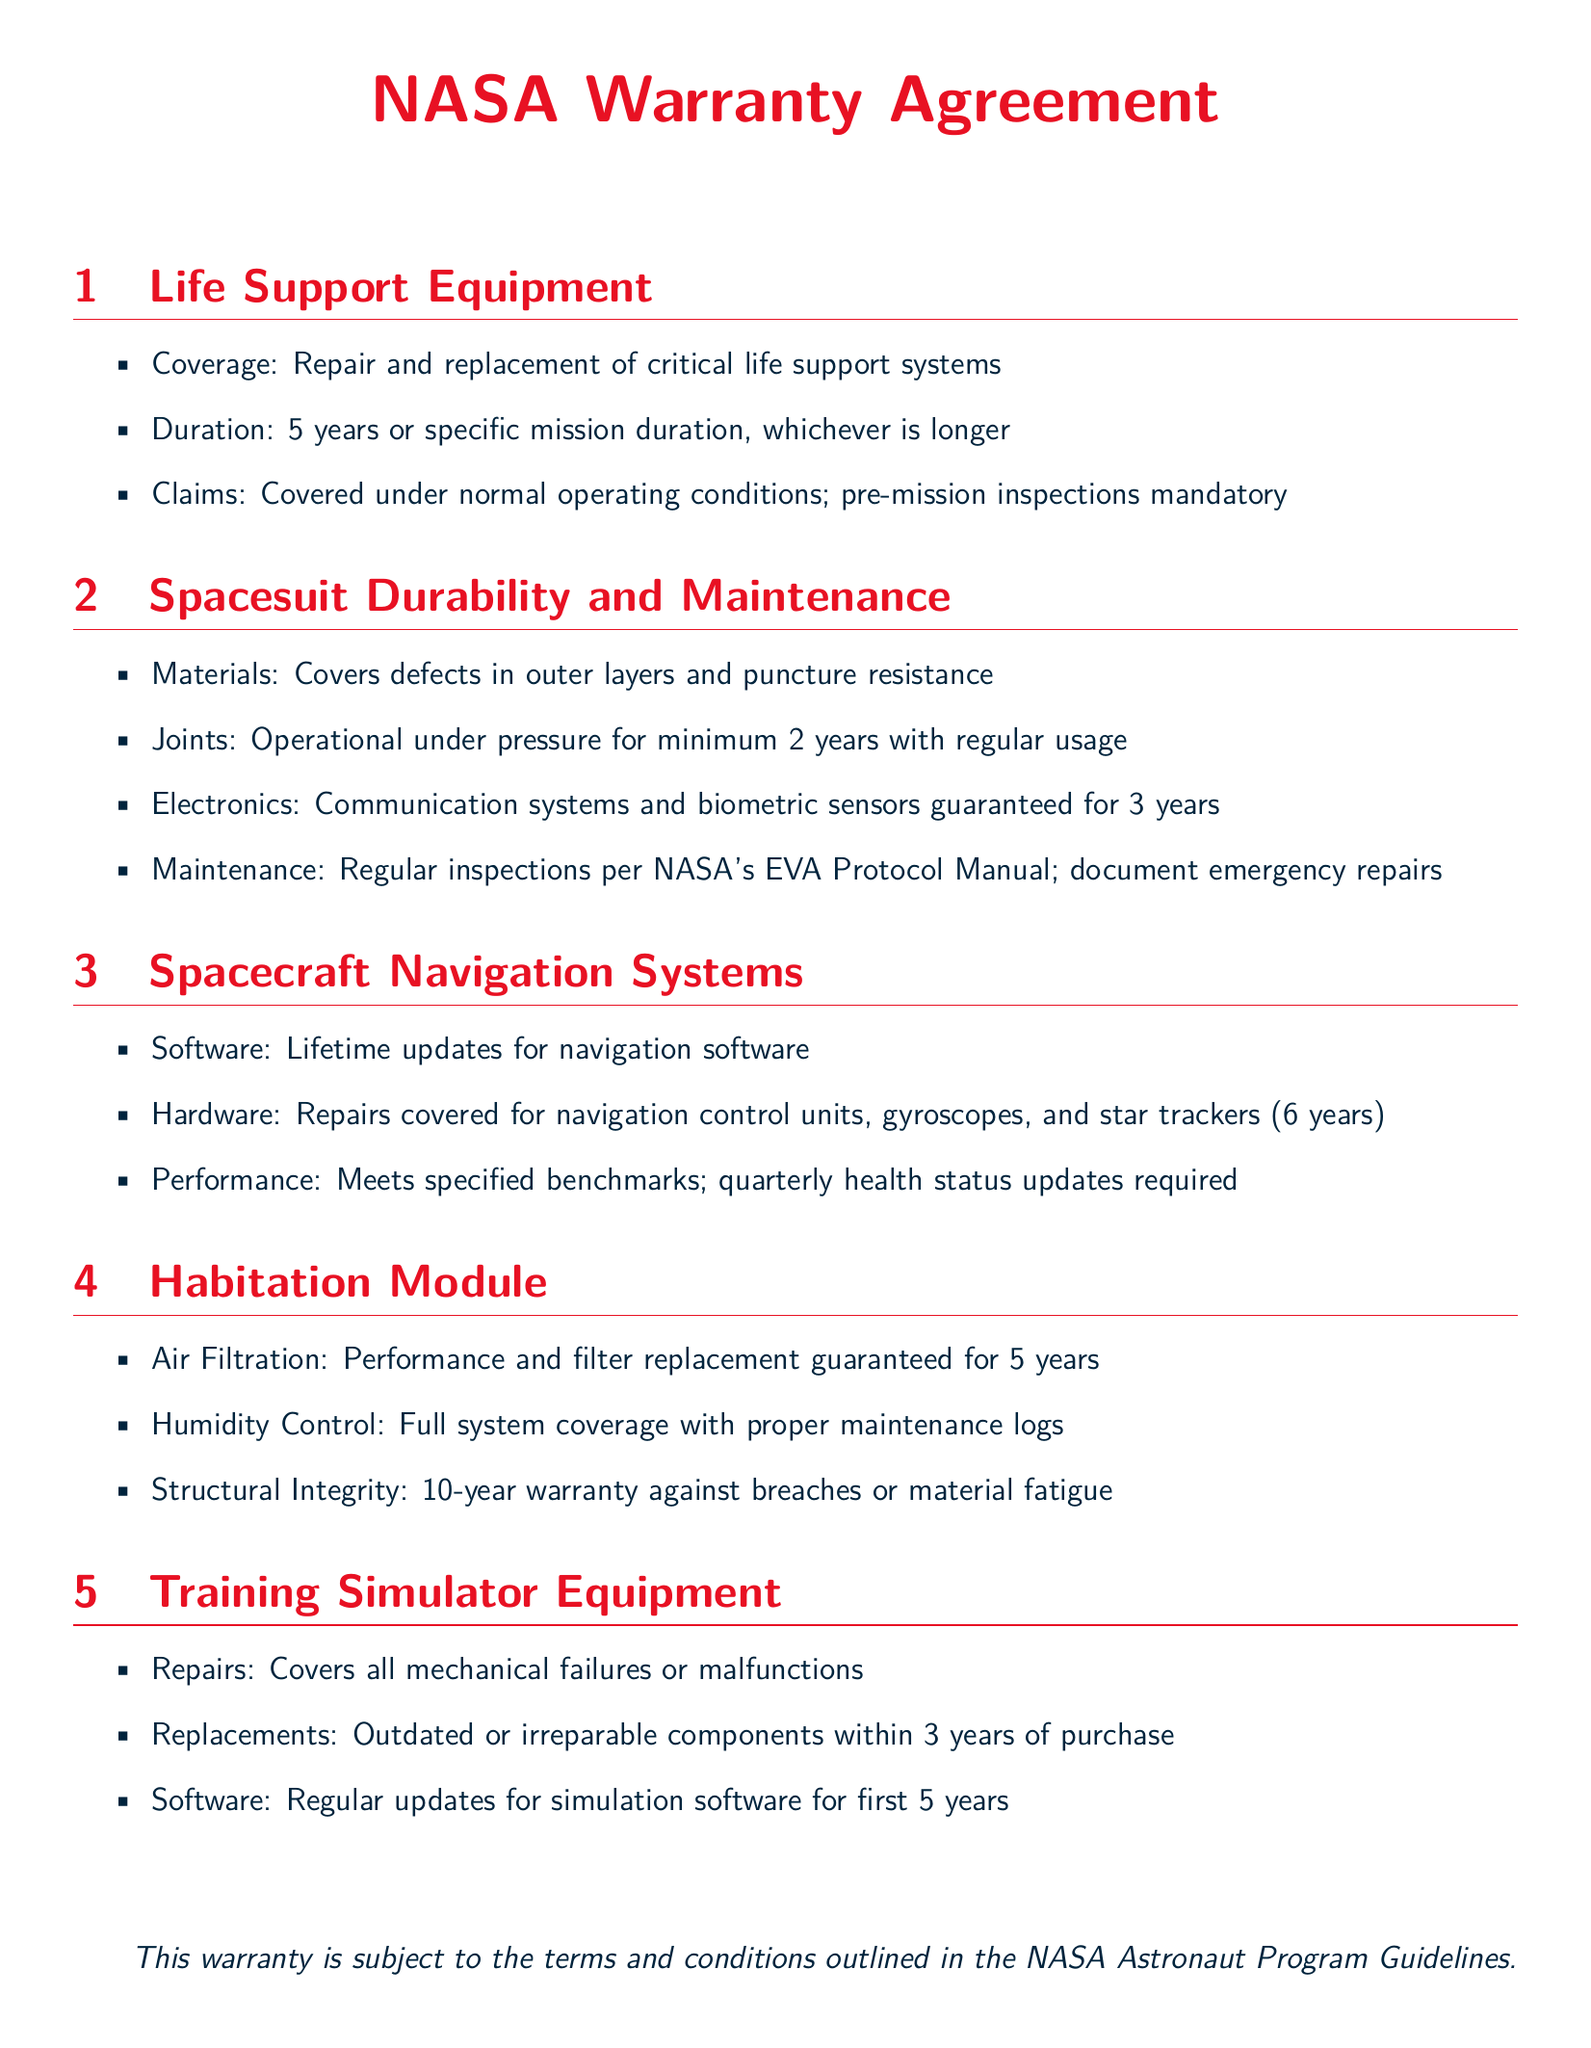What is the duration of the warranty for life support equipment? The duration of the warranty for life support equipment is specified as 5 years or specific mission duration, whichever is longer.
Answer: 5 years What is covered under the spacesuit durability warranty? The warranty covers defects in outer layers and puncture resistance, as well as joints and electronics.
Answer: Defects in outer layers and puncture resistance What is the warranty duration for hardware repairs on spacecraft navigation systems? The hardware repairs for navigation control units, gyroscopes, and star trackers are covered for 6 years.
Answer: 6 years What is guaranteed regarding air filtration in habitation modules? The air filtration's performance and filter replacement are guaranteed for 5 years.
Answer: 5 years How long is the warranty for structural integrity in habitation modules? The warranty against breaches or material fatigue for structural integrity is provided for 10 years.
Answer: 10 years What is the duration for software updates in training simulator equipment? The software updates are provided regularly for the first 5 years after purchase.
Answer: 5 years What maintenance guidelines are required for spacesuits? Regular inspections are required per NASA's EVA Protocol Manual, and emergency repairs must be documented.
Answer: Regular inspections per NASA's EVA Protocol Manual What is the warranty on mechanical failures for training simulator equipment? The warranty covers all mechanical failures or malfunctions, ensuring equipment reliability during training.
Answer: All mechanical failures What is the duration of the warranty for electronic components in spacesuits? The electronic components, including communication systems and biometric sensors, are guaranteed for 3 years.
Answer: 3 years 